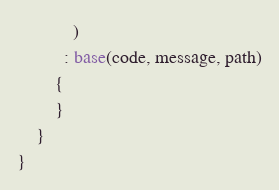Convert code to text. <code><loc_0><loc_0><loc_500><loc_500><_C#_>            )
          : base(code, message, path)
        {
        }
    }
}
</code> 